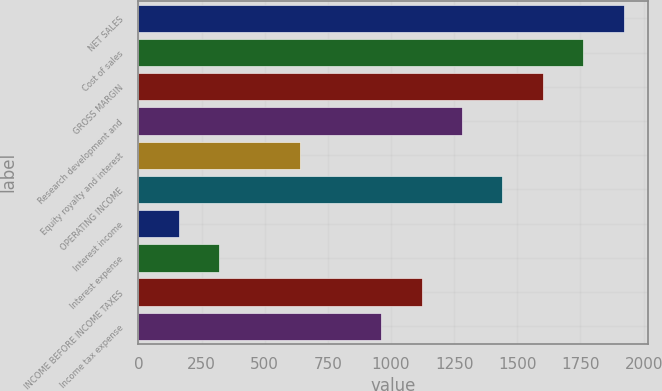<chart> <loc_0><loc_0><loc_500><loc_500><bar_chart><fcel>NET SALES<fcel>Cost of sales<fcel>GROSS MARGIN<fcel>Research development and<fcel>Equity royalty and interest<fcel>OPERATING INCOME<fcel>Interest income<fcel>Interest expense<fcel>INCOME BEFORE INCOME TAXES<fcel>Income tax expense<nl><fcel>1921.11<fcel>1761.05<fcel>1600.99<fcel>1280.87<fcel>640.63<fcel>1440.93<fcel>160.45<fcel>320.51<fcel>1120.81<fcel>960.75<nl></chart> 